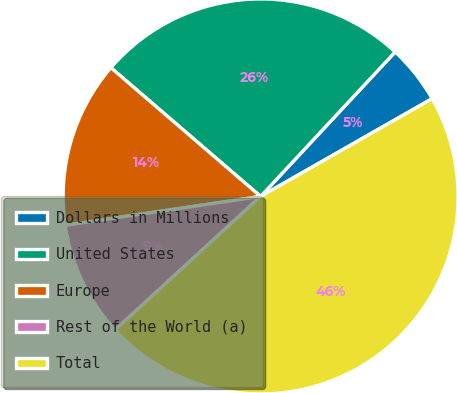<chart> <loc_0><loc_0><loc_500><loc_500><pie_chart><fcel>Dollars in Millions<fcel>United States<fcel>Europe<fcel>Rest of the World (a)<fcel>Total<nl><fcel>4.82%<fcel>25.63%<fcel>13.64%<fcel>9.48%<fcel>46.44%<nl></chart> 